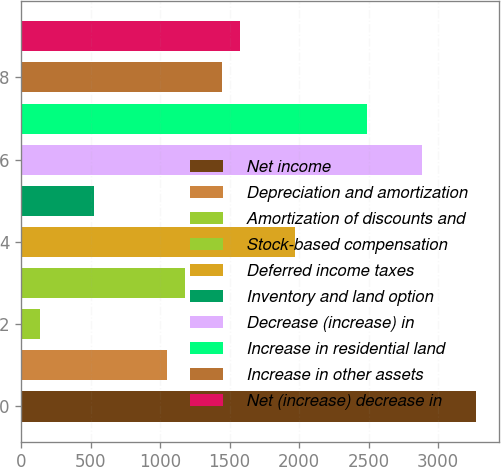<chart> <loc_0><loc_0><loc_500><loc_500><bar_chart><fcel>Net income<fcel>Depreciation and amortization<fcel>Amortization of discounts and<fcel>Stock-based compensation<fcel>Deferred income taxes<fcel>Inventory and land option<fcel>Decrease (increase) in<fcel>Increase in residential land<fcel>Increase in other assets<fcel>Net (increase) decrease in<nl><fcel>3275.6<fcel>1050.98<fcel>134.96<fcel>1181.84<fcel>1967<fcel>527.54<fcel>2883.02<fcel>2490.44<fcel>1443.56<fcel>1574.42<nl></chart> 